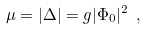<formula> <loc_0><loc_0><loc_500><loc_500>\mu = | \Delta | = g | \Phi _ { 0 } | ^ { 2 } \ ,</formula> 